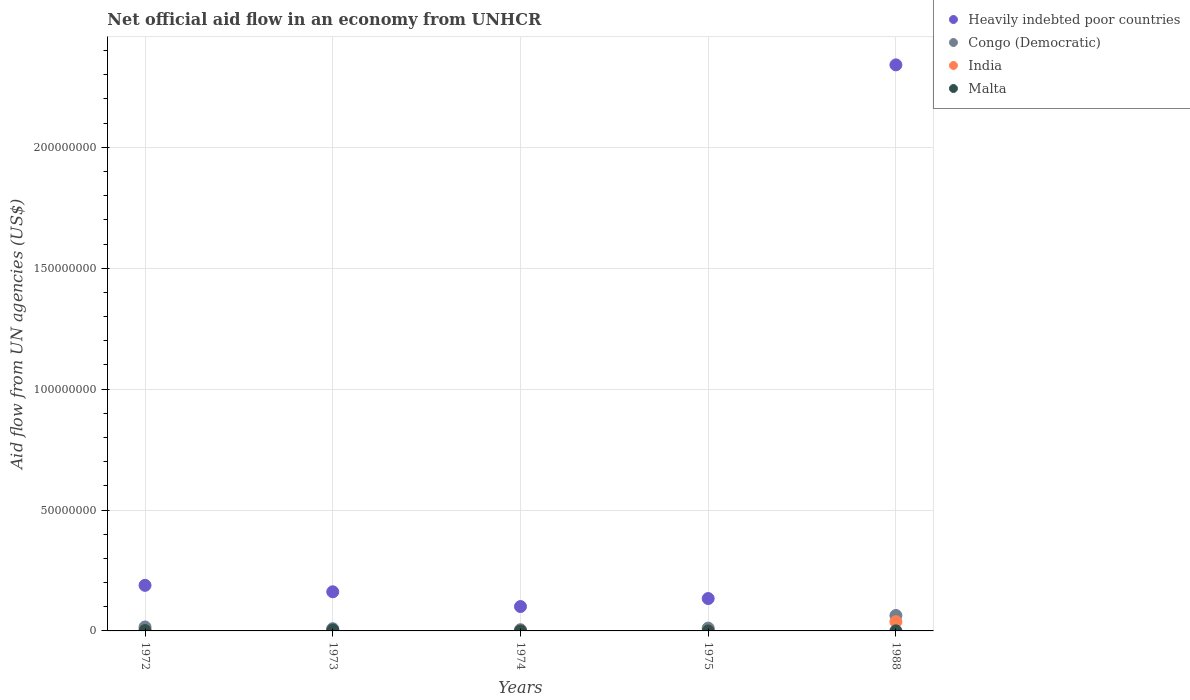What is the net official aid flow in Heavily indebted poor countries in 1974?
Offer a terse response. 1.01e+07. Across all years, what is the minimum net official aid flow in Congo (Democratic)?
Give a very brief answer. 5.00e+05. In which year was the net official aid flow in Congo (Democratic) minimum?
Make the answer very short. 1974. What is the difference between the net official aid flow in Malta in 1974 and that in 1988?
Your response must be concise. 0. What is the difference between the net official aid flow in Congo (Democratic) in 1973 and the net official aid flow in Malta in 1972?
Provide a short and direct response. 7.40e+05. What is the average net official aid flow in Malta per year?
Your response must be concise. 1.32e+05. In the year 1975, what is the difference between the net official aid flow in Congo (Democratic) and net official aid flow in Heavily indebted poor countries?
Your answer should be very brief. -1.22e+07. What is the ratio of the net official aid flow in Heavily indebted poor countries in 1975 to that in 1988?
Your answer should be very brief. 0.06. What is the difference between the highest and the second highest net official aid flow in Malta?
Offer a very short reply. 2.30e+05. What is the difference between the highest and the lowest net official aid flow in Malta?
Offer a terse response. 3.70e+05. In how many years, is the net official aid flow in India greater than the average net official aid flow in India taken over all years?
Make the answer very short. 1. Is it the case that in every year, the sum of the net official aid flow in Malta and net official aid flow in Congo (Democratic)  is greater than the sum of net official aid flow in India and net official aid flow in Heavily indebted poor countries?
Provide a succinct answer. No. Is the net official aid flow in Congo (Democratic) strictly less than the net official aid flow in India over the years?
Provide a short and direct response. No. What is the difference between two consecutive major ticks on the Y-axis?
Offer a very short reply. 5.00e+07. Are the values on the major ticks of Y-axis written in scientific E-notation?
Offer a very short reply. No. Does the graph contain any zero values?
Make the answer very short. No. How many legend labels are there?
Ensure brevity in your answer.  4. What is the title of the graph?
Provide a succinct answer. Net official aid flow in an economy from UNHCR. What is the label or title of the X-axis?
Provide a succinct answer. Years. What is the label or title of the Y-axis?
Provide a short and direct response. Aid flow from UN agencies (US$). What is the Aid flow from UN agencies (US$) in Heavily indebted poor countries in 1972?
Provide a short and direct response. 1.88e+07. What is the Aid flow from UN agencies (US$) in Congo (Democratic) in 1972?
Provide a short and direct response. 1.64e+06. What is the Aid flow from UN agencies (US$) of Malta in 1972?
Your answer should be very brief. 1.70e+05. What is the Aid flow from UN agencies (US$) of Heavily indebted poor countries in 1973?
Your answer should be compact. 1.62e+07. What is the Aid flow from UN agencies (US$) of Congo (Democratic) in 1973?
Provide a succinct answer. 9.10e+05. What is the Aid flow from UN agencies (US$) of Malta in 1973?
Make the answer very short. 4.00e+05. What is the Aid flow from UN agencies (US$) of Heavily indebted poor countries in 1974?
Your answer should be compact. 1.01e+07. What is the Aid flow from UN agencies (US$) in India in 1974?
Provide a short and direct response. 1.00e+05. What is the Aid flow from UN agencies (US$) in Heavily indebted poor countries in 1975?
Your answer should be compact. 1.34e+07. What is the Aid flow from UN agencies (US$) of Congo (Democratic) in 1975?
Offer a terse response. 1.17e+06. What is the Aid flow from UN agencies (US$) of Malta in 1975?
Offer a terse response. 3.00e+04. What is the Aid flow from UN agencies (US$) in Heavily indebted poor countries in 1988?
Offer a very short reply. 2.34e+08. What is the Aid flow from UN agencies (US$) in Congo (Democratic) in 1988?
Offer a very short reply. 6.38e+06. What is the Aid flow from UN agencies (US$) of India in 1988?
Your answer should be compact. 3.82e+06. What is the Aid flow from UN agencies (US$) in Malta in 1988?
Keep it short and to the point. 3.00e+04. Across all years, what is the maximum Aid flow from UN agencies (US$) in Heavily indebted poor countries?
Keep it short and to the point. 2.34e+08. Across all years, what is the maximum Aid flow from UN agencies (US$) of Congo (Democratic)?
Provide a short and direct response. 6.38e+06. Across all years, what is the maximum Aid flow from UN agencies (US$) in India?
Ensure brevity in your answer.  3.82e+06. Across all years, what is the maximum Aid flow from UN agencies (US$) of Malta?
Your response must be concise. 4.00e+05. Across all years, what is the minimum Aid flow from UN agencies (US$) of Heavily indebted poor countries?
Your response must be concise. 1.01e+07. Across all years, what is the minimum Aid flow from UN agencies (US$) in India?
Give a very brief answer. 10000. Across all years, what is the minimum Aid flow from UN agencies (US$) of Malta?
Provide a short and direct response. 3.00e+04. What is the total Aid flow from UN agencies (US$) in Heavily indebted poor countries in the graph?
Provide a succinct answer. 2.93e+08. What is the total Aid flow from UN agencies (US$) in Congo (Democratic) in the graph?
Make the answer very short. 1.06e+07. What is the total Aid flow from UN agencies (US$) of India in the graph?
Make the answer very short. 4.29e+06. What is the total Aid flow from UN agencies (US$) of Malta in the graph?
Provide a succinct answer. 6.60e+05. What is the difference between the Aid flow from UN agencies (US$) in Heavily indebted poor countries in 1972 and that in 1973?
Give a very brief answer. 2.67e+06. What is the difference between the Aid flow from UN agencies (US$) in Congo (Democratic) in 1972 and that in 1973?
Offer a terse response. 7.30e+05. What is the difference between the Aid flow from UN agencies (US$) of India in 1972 and that in 1973?
Offer a very short reply. -1.00e+05. What is the difference between the Aid flow from UN agencies (US$) in Malta in 1972 and that in 1973?
Offer a very short reply. -2.30e+05. What is the difference between the Aid flow from UN agencies (US$) in Heavily indebted poor countries in 1972 and that in 1974?
Ensure brevity in your answer.  8.77e+06. What is the difference between the Aid flow from UN agencies (US$) of Congo (Democratic) in 1972 and that in 1974?
Your response must be concise. 1.14e+06. What is the difference between the Aid flow from UN agencies (US$) in India in 1972 and that in 1974?
Provide a short and direct response. 3.00e+04. What is the difference between the Aid flow from UN agencies (US$) in Heavily indebted poor countries in 1972 and that in 1975?
Offer a very short reply. 5.46e+06. What is the difference between the Aid flow from UN agencies (US$) of India in 1972 and that in 1975?
Offer a terse response. 1.20e+05. What is the difference between the Aid flow from UN agencies (US$) in Malta in 1972 and that in 1975?
Keep it short and to the point. 1.40e+05. What is the difference between the Aid flow from UN agencies (US$) of Heavily indebted poor countries in 1972 and that in 1988?
Make the answer very short. -2.15e+08. What is the difference between the Aid flow from UN agencies (US$) of Congo (Democratic) in 1972 and that in 1988?
Provide a short and direct response. -4.74e+06. What is the difference between the Aid flow from UN agencies (US$) in India in 1972 and that in 1988?
Provide a short and direct response. -3.69e+06. What is the difference between the Aid flow from UN agencies (US$) of Heavily indebted poor countries in 1973 and that in 1974?
Your answer should be very brief. 6.10e+06. What is the difference between the Aid flow from UN agencies (US$) in Heavily indebted poor countries in 1973 and that in 1975?
Keep it short and to the point. 2.79e+06. What is the difference between the Aid flow from UN agencies (US$) of Malta in 1973 and that in 1975?
Your answer should be very brief. 3.70e+05. What is the difference between the Aid flow from UN agencies (US$) in Heavily indebted poor countries in 1973 and that in 1988?
Give a very brief answer. -2.18e+08. What is the difference between the Aid flow from UN agencies (US$) of Congo (Democratic) in 1973 and that in 1988?
Your response must be concise. -5.47e+06. What is the difference between the Aid flow from UN agencies (US$) of India in 1973 and that in 1988?
Ensure brevity in your answer.  -3.59e+06. What is the difference between the Aid flow from UN agencies (US$) of Heavily indebted poor countries in 1974 and that in 1975?
Provide a succinct answer. -3.31e+06. What is the difference between the Aid flow from UN agencies (US$) of Congo (Democratic) in 1974 and that in 1975?
Your answer should be very brief. -6.70e+05. What is the difference between the Aid flow from UN agencies (US$) of India in 1974 and that in 1975?
Provide a succinct answer. 9.00e+04. What is the difference between the Aid flow from UN agencies (US$) of Heavily indebted poor countries in 1974 and that in 1988?
Make the answer very short. -2.24e+08. What is the difference between the Aid flow from UN agencies (US$) in Congo (Democratic) in 1974 and that in 1988?
Make the answer very short. -5.88e+06. What is the difference between the Aid flow from UN agencies (US$) in India in 1974 and that in 1988?
Your answer should be compact. -3.72e+06. What is the difference between the Aid flow from UN agencies (US$) of Malta in 1974 and that in 1988?
Your response must be concise. 0. What is the difference between the Aid flow from UN agencies (US$) of Heavily indebted poor countries in 1975 and that in 1988?
Give a very brief answer. -2.21e+08. What is the difference between the Aid flow from UN agencies (US$) of Congo (Democratic) in 1975 and that in 1988?
Provide a short and direct response. -5.21e+06. What is the difference between the Aid flow from UN agencies (US$) of India in 1975 and that in 1988?
Give a very brief answer. -3.81e+06. What is the difference between the Aid flow from UN agencies (US$) of Malta in 1975 and that in 1988?
Ensure brevity in your answer.  0. What is the difference between the Aid flow from UN agencies (US$) of Heavily indebted poor countries in 1972 and the Aid flow from UN agencies (US$) of Congo (Democratic) in 1973?
Your answer should be compact. 1.79e+07. What is the difference between the Aid flow from UN agencies (US$) of Heavily indebted poor countries in 1972 and the Aid flow from UN agencies (US$) of India in 1973?
Keep it short and to the point. 1.86e+07. What is the difference between the Aid flow from UN agencies (US$) of Heavily indebted poor countries in 1972 and the Aid flow from UN agencies (US$) of Malta in 1973?
Give a very brief answer. 1.84e+07. What is the difference between the Aid flow from UN agencies (US$) of Congo (Democratic) in 1972 and the Aid flow from UN agencies (US$) of India in 1973?
Your answer should be compact. 1.41e+06. What is the difference between the Aid flow from UN agencies (US$) of Congo (Democratic) in 1972 and the Aid flow from UN agencies (US$) of Malta in 1973?
Offer a very short reply. 1.24e+06. What is the difference between the Aid flow from UN agencies (US$) of India in 1972 and the Aid flow from UN agencies (US$) of Malta in 1973?
Give a very brief answer. -2.70e+05. What is the difference between the Aid flow from UN agencies (US$) in Heavily indebted poor countries in 1972 and the Aid flow from UN agencies (US$) in Congo (Democratic) in 1974?
Give a very brief answer. 1.84e+07. What is the difference between the Aid flow from UN agencies (US$) in Heavily indebted poor countries in 1972 and the Aid flow from UN agencies (US$) in India in 1974?
Ensure brevity in your answer.  1.88e+07. What is the difference between the Aid flow from UN agencies (US$) of Heavily indebted poor countries in 1972 and the Aid flow from UN agencies (US$) of Malta in 1974?
Your answer should be very brief. 1.88e+07. What is the difference between the Aid flow from UN agencies (US$) in Congo (Democratic) in 1972 and the Aid flow from UN agencies (US$) in India in 1974?
Provide a short and direct response. 1.54e+06. What is the difference between the Aid flow from UN agencies (US$) in Congo (Democratic) in 1972 and the Aid flow from UN agencies (US$) in Malta in 1974?
Give a very brief answer. 1.61e+06. What is the difference between the Aid flow from UN agencies (US$) of India in 1972 and the Aid flow from UN agencies (US$) of Malta in 1974?
Your response must be concise. 1.00e+05. What is the difference between the Aid flow from UN agencies (US$) of Heavily indebted poor countries in 1972 and the Aid flow from UN agencies (US$) of Congo (Democratic) in 1975?
Provide a short and direct response. 1.77e+07. What is the difference between the Aid flow from UN agencies (US$) of Heavily indebted poor countries in 1972 and the Aid flow from UN agencies (US$) of India in 1975?
Your response must be concise. 1.88e+07. What is the difference between the Aid flow from UN agencies (US$) of Heavily indebted poor countries in 1972 and the Aid flow from UN agencies (US$) of Malta in 1975?
Offer a terse response. 1.88e+07. What is the difference between the Aid flow from UN agencies (US$) in Congo (Democratic) in 1972 and the Aid flow from UN agencies (US$) in India in 1975?
Provide a succinct answer. 1.63e+06. What is the difference between the Aid flow from UN agencies (US$) in Congo (Democratic) in 1972 and the Aid flow from UN agencies (US$) in Malta in 1975?
Give a very brief answer. 1.61e+06. What is the difference between the Aid flow from UN agencies (US$) of Heavily indebted poor countries in 1972 and the Aid flow from UN agencies (US$) of Congo (Democratic) in 1988?
Give a very brief answer. 1.25e+07. What is the difference between the Aid flow from UN agencies (US$) of Heavily indebted poor countries in 1972 and the Aid flow from UN agencies (US$) of India in 1988?
Your answer should be very brief. 1.50e+07. What is the difference between the Aid flow from UN agencies (US$) in Heavily indebted poor countries in 1972 and the Aid flow from UN agencies (US$) in Malta in 1988?
Provide a succinct answer. 1.88e+07. What is the difference between the Aid flow from UN agencies (US$) of Congo (Democratic) in 1972 and the Aid flow from UN agencies (US$) of India in 1988?
Keep it short and to the point. -2.18e+06. What is the difference between the Aid flow from UN agencies (US$) of Congo (Democratic) in 1972 and the Aid flow from UN agencies (US$) of Malta in 1988?
Provide a succinct answer. 1.61e+06. What is the difference between the Aid flow from UN agencies (US$) of Heavily indebted poor countries in 1973 and the Aid flow from UN agencies (US$) of Congo (Democratic) in 1974?
Ensure brevity in your answer.  1.57e+07. What is the difference between the Aid flow from UN agencies (US$) of Heavily indebted poor countries in 1973 and the Aid flow from UN agencies (US$) of India in 1974?
Make the answer very short. 1.61e+07. What is the difference between the Aid flow from UN agencies (US$) of Heavily indebted poor countries in 1973 and the Aid flow from UN agencies (US$) of Malta in 1974?
Keep it short and to the point. 1.62e+07. What is the difference between the Aid flow from UN agencies (US$) of Congo (Democratic) in 1973 and the Aid flow from UN agencies (US$) of India in 1974?
Make the answer very short. 8.10e+05. What is the difference between the Aid flow from UN agencies (US$) in Congo (Democratic) in 1973 and the Aid flow from UN agencies (US$) in Malta in 1974?
Make the answer very short. 8.80e+05. What is the difference between the Aid flow from UN agencies (US$) in Heavily indebted poor countries in 1973 and the Aid flow from UN agencies (US$) in Congo (Democratic) in 1975?
Ensure brevity in your answer.  1.50e+07. What is the difference between the Aid flow from UN agencies (US$) of Heavily indebted poor countries in 1973 and the Aid flow from UN agencies (US$) of India in 1975?
Give a very brief answer. 1.62e+07. What is the difference between the Aid flow from UN agencies (US$) in Heavily indebted poor countries in 1973 and the Aid flow from UN agencies (US$) in Malta in 1975?
Give a very brief answer. 1.62e+07. What is the difference between the Aid flow from UN agencies (US$) in Congo (Democratic) in 1973 and the Aid flow from UN agencies (US$) in Malta in 1975?
Offer a very short reply. 8.80e+05. What is the difference between the Aid flow from UN agencies (US$) in Heavily indebted poor countries in 1973 and the Aid flow from UN agencies (US$) in Congo (Democratic) in 1988?
Offer a very short reply. 9.80e+06. What is the difference between the Aid flow from UN agencies (US$) in Heavily indebted poor countries in 1973 and the Aid flow from UN agencies (US$) in India in 1988?
Keep it short and to the point. 1.24e+07. What is the difference between the Aid flow from UN agencies (US$) of Heavily indebted poor countries in 1973 and the Aid flow from UN agencies (US$) of Malta in 1988?
Give a very brief answer. 1.62e+07. What is the difference between the Aid flow from UN agencies (US$) in Congo (Democratic) in 1973 and the Aid flow from UN agencies (US$) in India in 1988?
Your answer should be very brief. -2.91e+06. What is the difference between the Aid flow from UN agencies (US$) in Congo (Democratic) in 1973 and the Aid flow from UN agencies (US$) in Malta in 1988?
Provide a short and direct response. 8.80e+05. What is the difference between the Aid flow from UN agencies (US$) of Heavily indebted poor countries in 1974 and the Aid flow from UN agencies (US$) of Congo (Democratic) in 1975?
Offer a very short reply. 8.91e+06. What is the difference between the Aid flow from UN agencies (US$) in Heavily indebted poor countries in 1974 and the Aid flow from UN agencies (US$) in India in 1975?
Offer a very short reply. 1.01e+07. What is the difference between the Aid flow from UN agencies (US$) of Heavily indebted poor countries in 1974 and the Aid flow from UN agencies (US$) of Malta in 1975?
Provide a short and direct response. 1.00e+07. What is the difference between the Aid flow from UN agencies (US$) of Congo (Democratic) in 1974 and the Aid flow from UN agencies (US$) of India in 1975?
Provide a short and direct response. 4.90e+05. What is the difference between the Aid flow from UN agencies (US$) in India in 1974 and the Aid flow from UN agencies (US$) in Malta in 1975?
Offer a very short reply. 7.00e+04. What is the difference between the Aid flow from UN agencies (US$) of Heavily indebted poor countries in 1974 and the Aid flow from UN agencies (US$) of Congo (Democratic) in 1988?
Give a very brief answer. 3.70e+06. What is the difference between the Aid flow from UN agencies (US$) in Heavily indebted poor countries in 1974 and the Aid flow from UN agencies (US$) in India in 1988?
Ensure brevity in your answer.  6.26e+06. What is the difference between the Aid flow from UN agencies (US$) in Heavily indebted poor countries in 1974 and the Aid flow from UN agencies (US$) in Malta in 1988?
Provide a succinct answer. 1.00e+07. What is the difference between the Aid flow from UN agencies (US$) of Congo (Democratic) in 1974 and the Aid flow from UN agencies (US$) of India in 1988?
Your answer should be compact. -3.32e+06. What is the difference between the Aid flow from UN agencies (US$) of India in 1974 and the Aid flow from UN agencies (US$) of Malta in 1988?
Ensure brevity in your answer.  7.00e+04. What is the difference between the Aid flow from UN agencies (US$) in Heavily indebted poor countries in 1975 and the Aid flow from UN agencies (US$) in Congo (Democratic) in 1988?
Provide a succinct answer. 7.01e+06. What is the difference between the Aid flow from UN agencies (US$) in Heavily indebted poor countries in 1975 and the Aid flow from UN agencies (US$) in India in 1988?
Your answer should be compact. 9.57e+06. What is the difference between the Aid flow from UN agencies (US$) of Heavily indebted poor countries in 1975 and the Aid flow from UN agencies (US$) of Malta in 1988?
Offer a very short reply. 1.34e+07. What is the difference between the Aid flow from UN agencies (US$) in Congo (Democratic) in 1975 and the Aid flow from UN agencies (US$) in India in 1988?
Ensure brevity in your answer.  -2.65e+06. What is the difference between the Aid flow from UN agencies (US$) of Congo (Democratic) in 1975 and the Aid flow from UN agencies (US$) of Malta in 1988?
Provide a short and direct response. 1.14e+06. What is the average Aid flow from UN agencies (US$) of Heavily indebted poor countries per year?
Your answer should be very brief. 5.85e+07. What is the average Aid flow from UN agencies (US$) in Congo (Democratic) per year?
Provide a short and direct response. 2.12e+06. What is the average Aid flow from UN agencies (US$) of India per year?
Your response must be concise. 8.58e+05. What is the average Aid flow from UN agencies (US$) of Malta per year?
Give a very brief answer. 1.32e+05. In the year 1972, what is the difference between the Aid flow from UN agencies (US$) in Heavily indebted poor countries and Aid flow from UN agencies (US$) in Congo (Democratic)?
Make the answer very short. 1.72e+07. In the year 1972, what is the difference between the Aid flow from UN agencies (US$) in Heavily indebted poor countries and Aid flow from UN agencies (US$) in India?
Your answer should be compact. 1.87e+07. In the year 1972, what is the difference between the Aid flow from UN agencies (US$) of Heavily indebted poor countries and Aid flow from UN agencies (US$) of Malta?
Keep it short and to the point. 1.87e+07. In the year 1972, what is the difference between the Aid flow from UN agencies (US$) in Congo (Democratic) and Aid flow from UN agencies (US$) in India?
Offer a very short reply. 1.51e+06. In the year 1972, what is the difference between the Aid flow from UN agencies (US$) in Congo (Democratic) and Aid flow from UN agencies (US$) in Malta?
Offer a very short reply. 1.47e+06. In the year 1973, what is the difference between the Aid flow from UN agencies (US$) in Heavily indebted poor countries and Aid flow from UN agencies (US$) in Congo (Democratic)?
Your answer should be compact. 1.53e+07. In the year 1973, what is the difference between the Aid flow from UN agencies (US$) of Heavily indebted poor countries and Aid flow from UN agencies (US$) of India?
Your answer should be very brief. 1.60e+07. In the year 1973, what is the difference between the Aid flow from UN agencies (US$) of Heavily indebted poor countries and Aid flow from UN agencies (US$) of Malta?
Keep it short and to the point. 1.58e+07. In the year 1973, what is the difference between the Aid flow from UN agencies (US$) of Congo (Democratic) and Aid flow from UN agencies (US$) of India?
Keep it short and to the point. 6.80e+05. In the year 1973, what is the difference between the Aid flow from UN agencies (US$) in Congo (Democratic) and Aid flow from UN agencies (US$) in Malta?
Make the answer very short. 5.10e+05. In the year 1974, what is the difference between the Aid flow from UN agencies (US$) of Heavily indebted poor countries and Aid flow from UN agencies (US$) of Congo (Democratic)?
Ensure brevity in your answer.  9.58e+06. In the year 1974, what is the difference between the Aid flow from UN agencies (US$) in Heavily indebted poor countries and Aid flow from UN agencies (US$) in India?
Your answer should be very brief. 9.98e+06. In the year 1974, what is the difference between the Aid flow from UN agencies (US$) of Heavily indebted poor countries and Aid flow from UN agencies (US$) of Malta?
Ensure brevity in your answer.  1.00e+07. In the year 1974, what is the difference between the Aid flow from UN agencies (US$) in Congo (Democratic) and Aid flow from UN agencies (US$) in India?
Your answer should be compact. 4.00e+05. In the year 1974, what is the difference between the Aid flow from UN agencies (US$) in Congo (Democratic) and Aid flow from UN agencies (US$) in Malta?
Provide a succinct answer. 4.70e+05. In the year 1975, what is the difference between the Aid flow from UN agencies (US$) of Heavily indebted poor countries and Aid flow from UN agencies (US$) of Congo (Democratic)?
Offer a terse response. 1.22e+07. In the year 1975, what is the difference between the Aid flow from UN agencies (US$) of Heavily indebted poor countries and Aid flow from UN agencies (US$) of India?
Offer a very short reply. 1.34e+07. In the year 1975, what is the difference between the Aid flow from UN agencies (US$) of Heavily indebted poor countries and Aid flow from UN agencies (US$) of Malta?
Ensure brevity in your answer.  1.34e+07. In the year 1975, what is the difference between the Aid flow from UN agencies (US$) in Congo (Democratic) and Aid flow from UN agencies (US$) in India?
Make the answer very short. 1.16e+06. In the year 1975, what is the difference between the Aid flow from UN agencies (US$) of Congo (Democratic) and Aid flow from UN agencies (US$) of Malta?
Keep it short and to the point. 1.14e+06. In the year 1988, what is the difference between the Aid flow from UN agencies (US$) in Heavily indebted poor countries and Aid flow from UN agencies (US$) in Congo (Democratic)?
Give a very brief answer. 2.28e+08. In the year 1988, what is the difference between the Aid flow from UN agencies (US$) in Heavily indebted poor countries and Aid flow from UN agencies (US$) in India?
Offer a very short reply. 2.30e+08. In the year 1988, what is the difference between the Aid flow from UN agencies (US$) of Heavily indebted poor countries and Aid flow from UN agencies (US$) of Malta?
Ensure brevity in your answer.  2.34e+08. In the year 1988, what is the difference between the Aid flow from UN agencies (US$) in Congo (Democratic) and Aid flow from UN agencies (US$) in India?
Give a very brief answer. 2.56e+06. In the year 1988, what is the difference between the Aid flow from UN agencies (US$) of Congo (Democratic) and Aid flow from UN agencies (US$) of Malta?
Keep it short and to the point. 6.35e+06. In the year 1988, what is the difference between the Aid flow from UN agencies (US$) of India and Aid flow from UN agencies (US$) of Malta?
Offer a terse response. 3.79e+06. What is the ratio of the Aid flow from UN agencies (US$) in Heavily indebted poor countries in 1972 to that in 1973?
Offer a terse response. 1.17. What is the ratio of the Aid flow from UN agencies (US$) in Congo (Democratic) in 1972 to that in 1973?
Your answer should be very brief. 1.8. What is the ratio of the Aid flow from UN agencies (US$) of India in 1972 to that in 1973?
Keep it short and to the point. 0.57. What is the ratio of the Aid flow from UN agencies (US$) of Malta in 1972 to that in 1973?
Your response must be concise. 0.42. What is the ratio of the Aid flow from UN agencies (US$) in Heavily indebted poor countries in 1972 to that in 1974?
Your answer should be compact. 1.87. What is the ratio of the Aid flow from UN agencies (US$) of Congo (Democratic) in 1972 to that in 1974?
Make the answer very short. 3.28. What is the ratio of the Aid flow from UN agencies (US$) in India in 1972 to that in 1974?
Provide a succinct answer. 1.3. What is the ratio of the Aid flow from UN agencies (US$) of Malta in 1972 to that in 1974?
Keep it short and to the point. 5.67. What is the ratio of the Aid flow from UN agencies (US$) of Heavily indebted poor countries in 1972 to that in 1975?
Keep it short and to the point. 1.41. What is the ratio of the Aid flow from UN agencies (US$) of Congo (Democratic) in 1972 to that in 1975?
Ensure brevity in your answer.  1.4. What is the ratio of the Aid flow from UN agencies (US$) in India in 1972 to that in 1975?
Your response must be concise. 13. What is the ratio of the Aid flow from UN agencies (US$) in Malta in 1972 to that in 1975?
Provide a succinct answer. 5.67. What is the ratio of the Aid flow from UN agencies (US$) of Heavily indebted poor countries in 1972 to that in 1988?
Your answer should be compact. 0.08. What is the ratio of the Aid flow from UN agencies (US$) of Congo (Democratic) in 1972 to that in 1988?
Make the answer very short. 0.26. What is the ratio of the Aid flow from UN agencies (US$) in India in 1972 to that in 1988?
Provide a short and direct response. 0.03. What is the ratio of the Aid flow from UN agencies (US$) in Malta in 1972 to that in 1988?
Offer a very short reply. 5.67. What is the ratio of the Aid flow from UN agencies (US$) of Heavily indebted poor countries in 1973 to that in 1974?
Your answer should be compact. 1.61. What is the ratio of the Aid flow from UN agencies (US$) in Congo (Democratic) in 1973 to that in 1974?
Your answer should be very brief. 1.82. What is the ratio of the Aid flow from UN agencies (US$) in India in 1973 to that in 1974?
Your answer should be compact. 2.3. What is the ratio of the Aid flow from UN agencies (US$) in Malta in 1973 to that in 1974?
Provide a short and direct response. 13.33. What is the ratio of the Aid flow from UN agencies (US$) of Heavily indebted poor countries in 1973 to that in 1975?
Your answer should be very brief. 1.21. What is the ratio of the Aid flow from UN agencies (US$) of Congo (Democratic) in 1973 to that in 1975?
Offer a terse response. 0.78. What is the ratio of the Aid flow from UN agencies (US$) of Malta in 1973 to that in 1975?
Your answer should be very brief. 13.33. What is the ratio of the Aid flow from UN agencies (US$) in Heavily indebted poor countries in 1973 to that in 1988?
Ensure brevity in your answer.  0.07. What is the ratio of the Aid flow from UN agencies (US$) of Congo (Democratic) in 1973 to that in 1988?
Your answer should be very brief. 0.14. What is the ratio of the Aid flow from UN agencies (US$) in India in 1973 to that in 1988?
Your answer should be very brief. 0.06. What is the ratio of the Aid flow from UN agencies (US$) of Malta in 1973 to that in 1988?
Make the answer very short. 13.33. What is the ratio of the Aid flow from UN agencies (US$) in Heavily indebted poor countries in 1974 to that in 1975?
Make the answer very short. 0.75. What is the ratio of the Aid flow from UN agencies (US$) of Congo (Democratic) in 1974 to that in 1975?
Your response must be concise. 0.43. What is the ratio of the Aid flow from UN agencies (US$) of Malta in 1974 to that in 1975?
Keep it short and to the point. 1. What is the ratio of the Aid flow from UN agencies (US$) of Heavily indebted poor countries in 1974 to that in 1988?
Offer a terse response. 0.04. What is the ratio of the Aid flow from UN agencies (US$) in Congo (Democratic) in 1974 to that in 1988?
Provide a succinct answer. 0.08. What is the ratio of the Aid flow from UN agencies (US$) in India in 1974 to that in 1988?
Make the answer very short. 0.03. What is the ratio of the Aid flow from UN agencies (US$) of Malta in 1974 to that in 1988?
Your answer should be compact. 1. What is the ratio of the Aid flow from UN agencies (US$) in Heavily indebted poor countries in 1975 to that in 1988?
Your answer should be compact. 0.06. What is the ratio of the Aid flow from UN agencies (US$) in Congo (Democratic) in 1975 to that in 1988?
Offer a terse response. 0.18. What is the ratio of the Aid flow from UN agencies (US$) of India in 1975 to that in 1988?
Provide a short and direct response. 0. What is the difference between the highest and the second highest Aid flow from UN agencies (US$) of Heavily indebted poor countries?
Keep it short and to the point. 2.15e+08. What is the difference between the highest and the second highest Aid flow from UN agencies (US$) in Congo (Democratic)?
Your response must be concise. 4.74e+06. What is the difference between the highest and the second highest Aid flow from UN agencies (US$) in India?
Your response must be concise. 3.59e+06. What is the difference between the highest and the lowest Aid flow from UN agencies (US$) in Heavily indebted poor countries?
Your answer should be compact. 2.24e+08. What is the difference between the highest and the lowest Aid flow from UN agencies (US$) of Congo (Democratic)?
Provide a succinct answer. 5.88e+06. What is the difference between the highest and the lowest Aid flow from UN agencies (US$) in India?
Give a very brief answer. 3.81e+06. What is the difference between the highest and the lowest Aid flow from UN agencies (US$) of Malta?
Your answer should be very brief. 3.70e+05. 